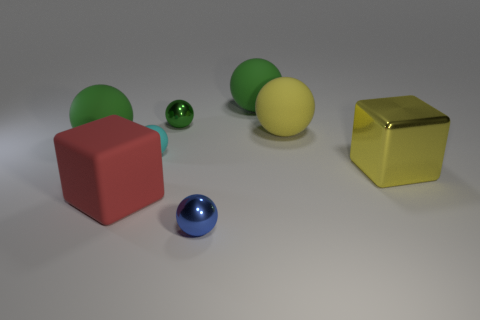How many green balls must be subtracted to get 1 green balls? 2 Subtract all small cyan rubber balls. How many balls are left? 5 Add 1 tiny things. How many objects exist? 9 Subtract all yellow balls. How many balls are left? 5 Subtract all blocks. How many objects are left? 6 Subtract all brown balls. How many blue blocks are left? 0 Add 5 red rubber things. How many red rubber things exist? 6 Subtract 0 blue blocks. How many objects are left? 8 Subtract 1 cubes. How many cubes are left? 1 Subtract all purple spheres. Subtract all gray blocks. How many spheres are left? 6 